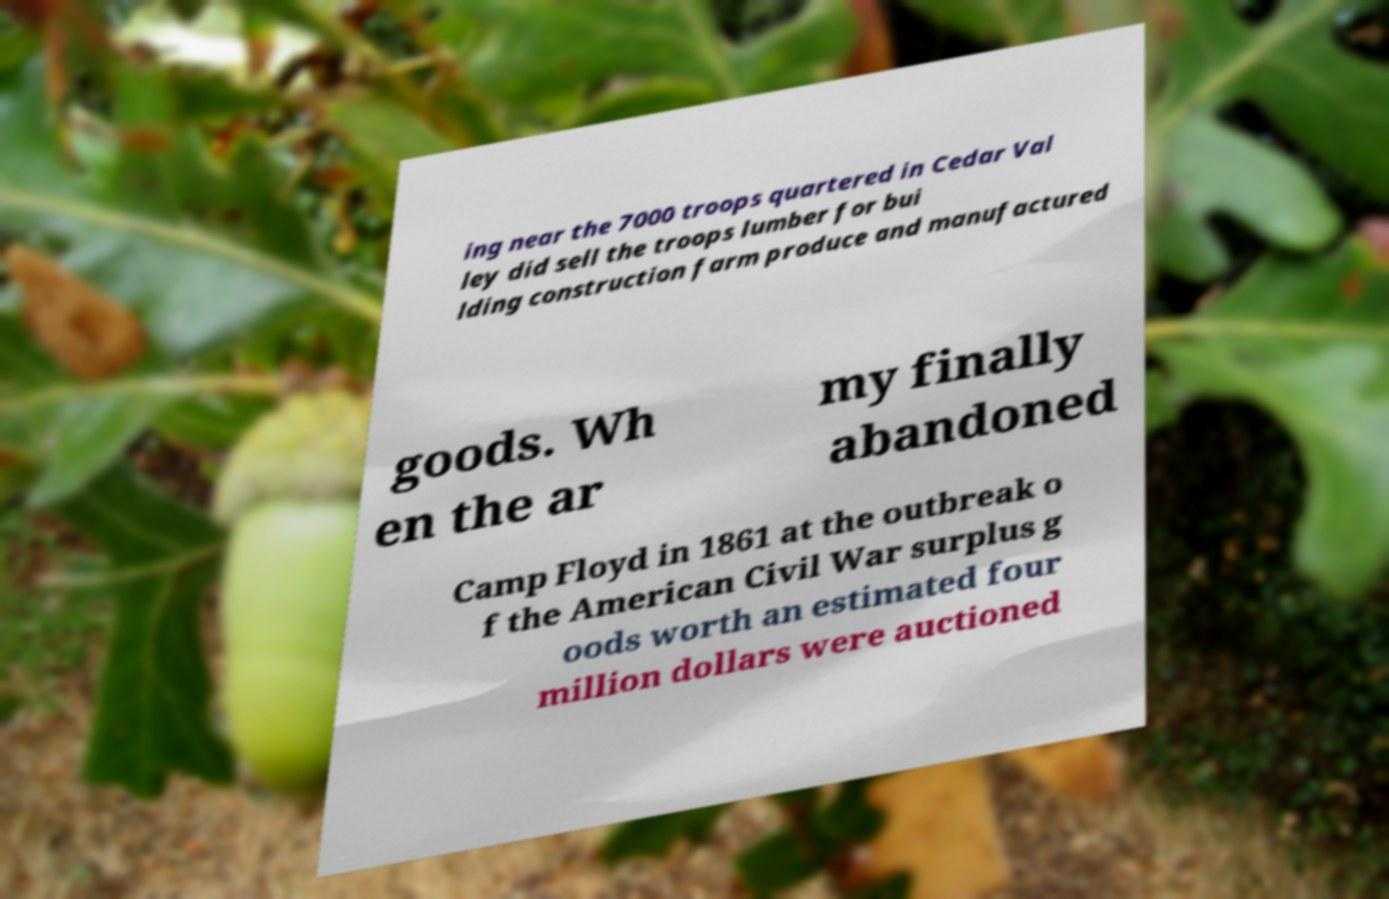Could you extract and type out the text from this image? ing near the 7000 troops quartered in Cedar Val ley did sell the troops lumber for bui lding construction farm produce and manufactured goods. Wh en the ar my finally abandoned Camp Floyd in 1861 at the outbreak o f the American Civil War surplus g oods worth an estimated four million dollars were auctioned 